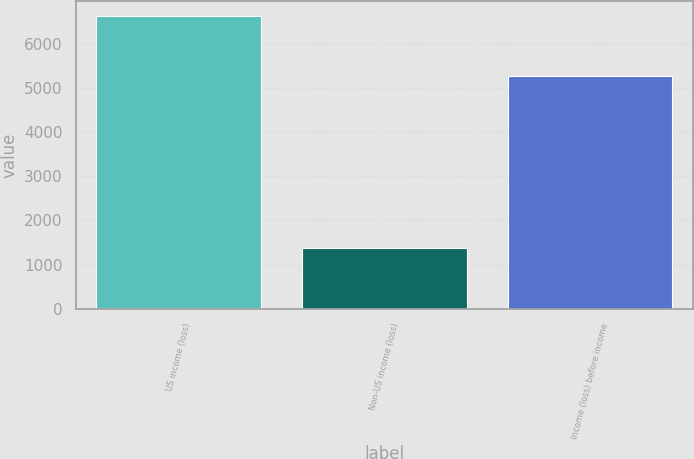<chart> <loc_0><loc_0><loc_500><loc_500><bar_chart><fcel>US income (loss)<fcel>Non-US income (loss)<fcel>Income (loss) before income<nl><fcel>6647<fcel>1364<fcel>5283<nl></chart> 